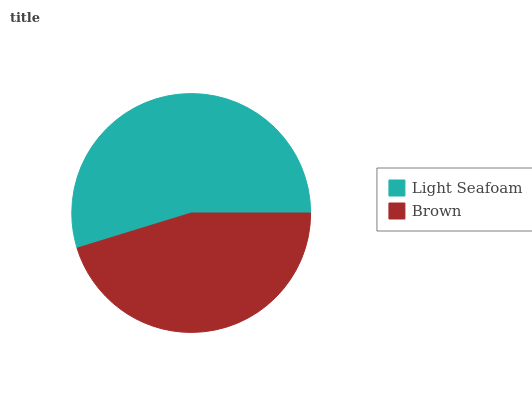Is Brown the minimum?
Answer yes or no. Yes. Is Light Seafoam the maximum?
Answer yes or no. Yes. Is Brown the maximum?
Answer yes or no. No. Is Light Seafoam greater than Brown?
Answer yes or no. Yes. Is Brown less than Light Seafoam?
Answer yes or no. Yes. Is Brown greater than Light Seafoam?
Answer yes or no. No. Is Light Seafoam less than Brown?
Answer yes or no. No. Is Light Seafoam the high median?
Answer yes or no. Yes. Is Brown the low median?
Answer yes or no. Yes. Is Brown the high median?
Answer yes or no. No. Is Light Seafoam the low median?
Answer yes or no. No. 